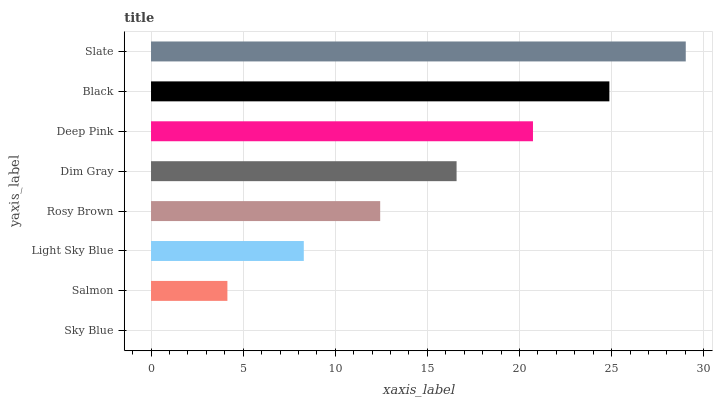Is Sky Blue the minimum?
Answer yes or no. Yes. Is Slate the maximum?
Answer yes or no. Yes. Is Salmon the minimum?
Answer yes or no. No. Is Salmon the maximum?
Answer yes or no. No. Is Salmon greater than Sky Blue?
Answer yes or no. Yes. Is Sky Blue less than Salmon?
Answer yes or no. Yes. Is Sky Blue greater than Salmon?
Answer yes or no. No. Is Salmon less than Sky Blue?
Answer yes or no. No. Is Dim Gray the high median?
Answer yes or no. Yes. Is Rosy Brown the low median?
Answer yes or no. Yes. Is Deep Pink the high median?
Answer yes or no. No. Is Slate the low median?
Answer yes or no. No. 